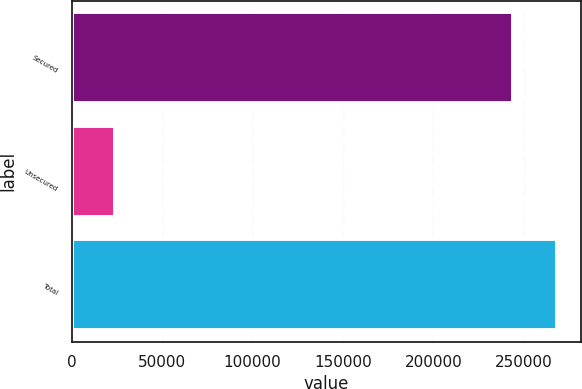<chart> <loc_0><loc_0><loc_500><loc_500><bar_chart><fcel>Secured<fcel>Unsecured<fcel>Total<nl><fcel>243900<fcel>23713<fcel>268290<nl></chart> 